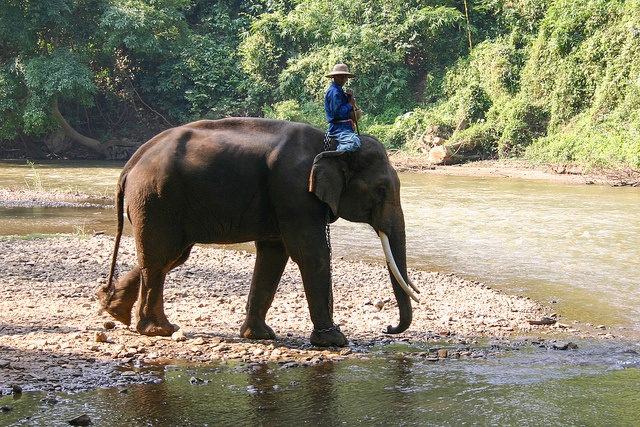Describe the objects in this image and their specific colors. I can see elephant in black, gray, and maroon tones and people in black, navy, gray, and blue tones in this image. 